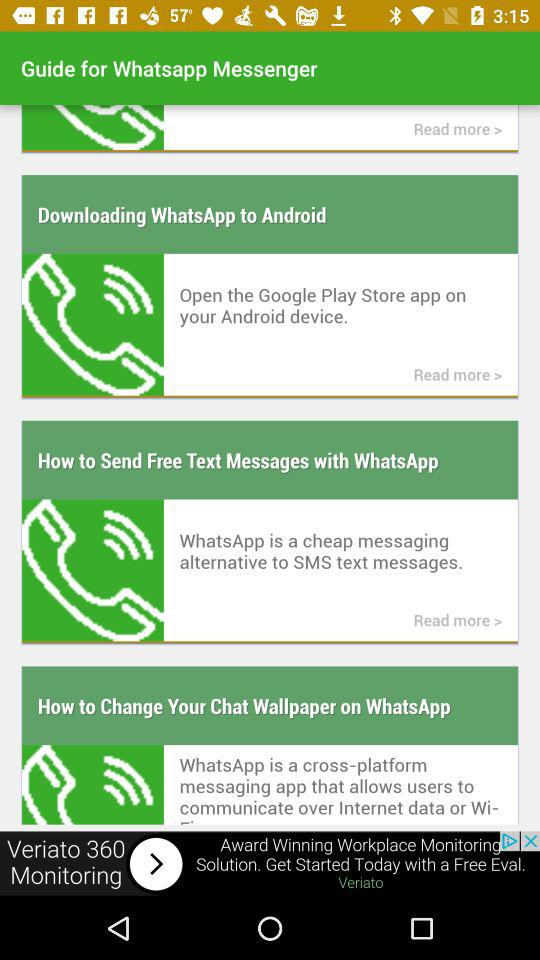How can we download the Whatsapp?
When the provided information is insufficient, respond with <no answer>. <no answer> 